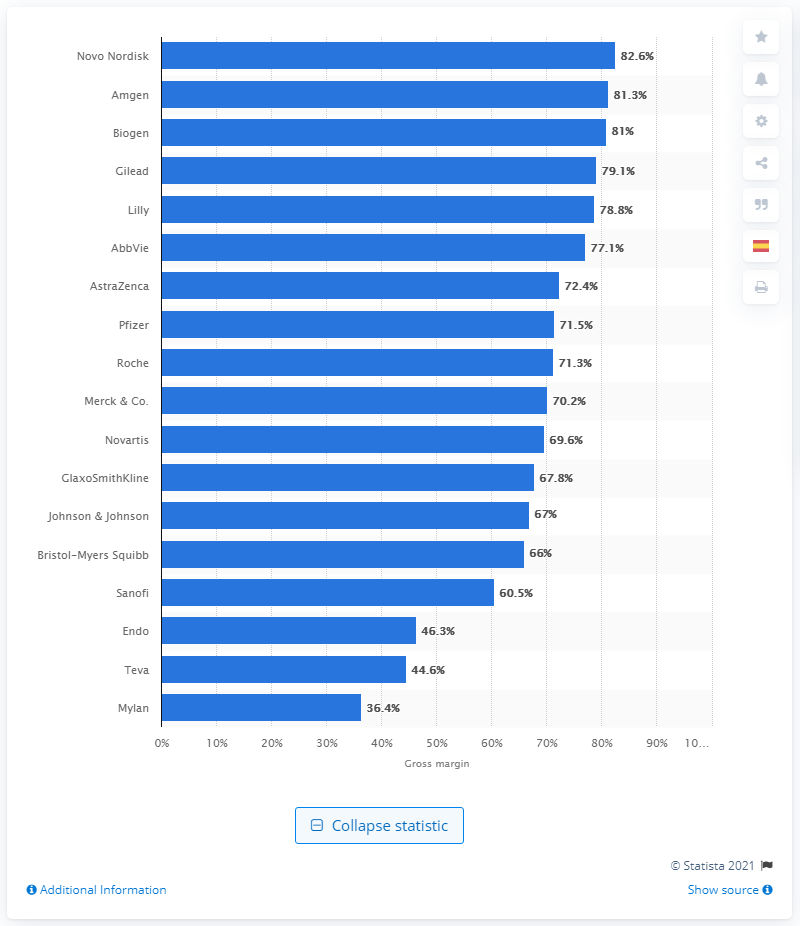Outline some significant characteristics in this image. Amgen was the pharmaceutical company with the highest gross margin in 2019. Novo Nordisk's gross margin in 2019 was 82.6%. In 2019, Amgen had the highest gross margin among all pharmaceutical companies. According to the information provided, Novo Nordisk was the pharmaceutical company with the highest gross margin in 2019. 